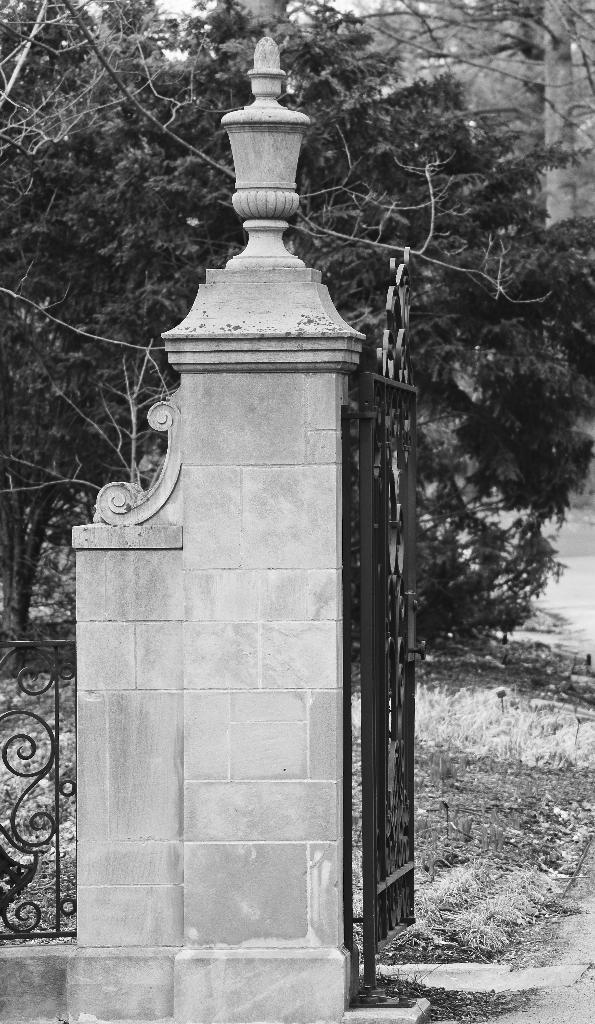What type of structure is present in the image? There is a metal gate and a metal fence in the image. What can be seen in the background of the image? Trees are visible in the image. What type of ground surface is present in the image? There is grass on the ground in the image. Where is the pancake located in the image? There is no pancake present in the image. What type of box can be seen in the image? There is no box present in the image. 